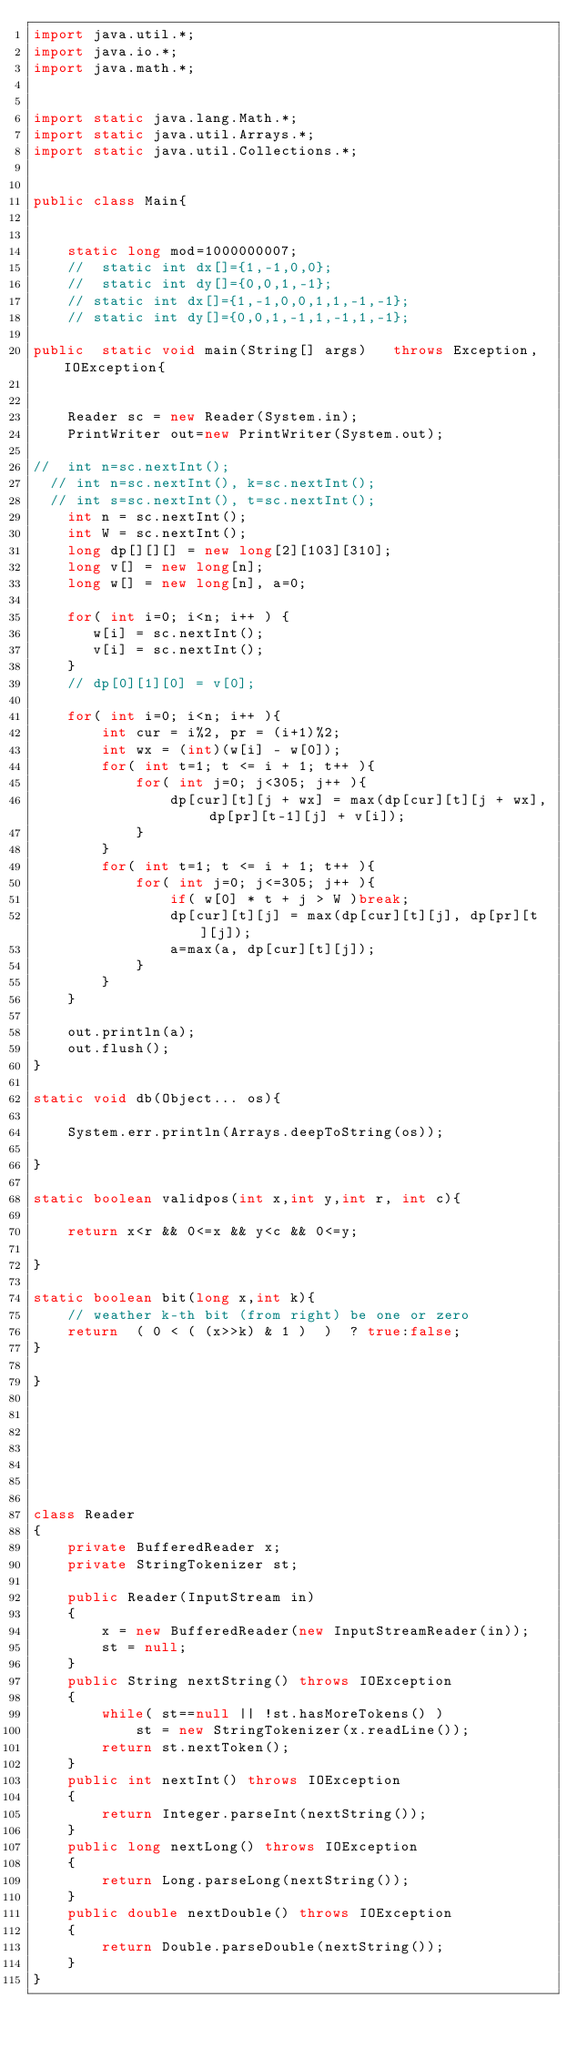<code> <loc_0><loc_0><loc_500><loc_500><_Java_>import java.util.*;
import java.io.*;
import java.math.*;


import static java.lang.Math.*;
import static java.util.Arrays.*;
import static java.util.Collections.*;


public class Main{ 


    static long mod=1000000007;
    //  static int dx[]={1,-1,0,0};
    //  static int dy[]={0,0,1,-1};
    // static int dx[]={1,-1,0,0,1,1,-1,-1};
    // static int dy[]={0,0,1,-1,1,-1,1,-1}; 

public  static void main(String[] args)   throws Exception, IOException{

    
    Reader sc = new Reader(System.in);
    PrintWriter out=new PrintWriter(System.out);

//  int n=sc.nextInt();  
  // int n=sc.nextInt(), k=sc.nextInt();  
  // int s=sc.nextInt(), t=sc.nextInt(); 
    int n = sc.nextInt();
    int W = sc.nextInt();
    long dp[][][] = new long[2][103][310];
    long v[] = new long[n];
    long w[] = new long[n], a=0;

    for( int i=0; i<n; i++ ) {
       w[i] = sc.nextInt();
       v[i] = sc.nextInt();
    }
    // dp[0][1][0] = v[0];

    for( int i=0; i<n; i++ ){
        int cur = i%2, pr = (i+1)%2;
        int wx = (int)(w[i] - w[0]); 
        for( int t=1; t <= i + 1; t++ ){
            for( int j=0; j<305; j++ ){
                dp[cur][t][j + wx] = max(dp[cur][t][j + wx], dp[pr][t-1][j] + v[i]);
            }
        }
        for( int t=1; t <= i + 1; t++ ){
            for( int j=0; j<=305; j++ ){
                if( w[0] * t + j > W )break;
                dp[cur][t][j] = max(dp[cur][t][j], dp[pr][t][j]);
                a=max(a, dp[cur][t][j]);
            }
        }
    }

    out.println(a);
    out.flush();
}

static void db(Object... os){

    System.err.println(Arrays.deepToString(os));

}

static boolean validpos(int x,int y,int r, int c){
    
    return x<r && 0<=x && y<c && 0<=y;
    
}
 
static boolean bit(long x,int k){
    // weather k-th bit (from right) be one or zero
    return  ( 0 < ( (x>>k) & 1 )  )  ? true:false;
}

}







class Reader
{ 
    private BufferedReader x;
    private StringTokenizer st;
    
    public Reader(InputStream in)
    {
        x = new BufferedReader(new InputStreamReader(in));
        st = null;
    }
    public String nextString() throws IOException
    {
        while( st==null || !st.hasMoreTokens() )
            st = new StringTokenizer(x.readLine());
        return st.nextToken();
    }
    public int nextInt() throws IOException
    {
        return Integer.parseInt(nextString());
    }
    public long nextLong() throws IOException
    {
        return Long.parseLong(nextString());
    }
    public double nextDouble() throws IOException
    {
        return Double.parseDouble(nextString());
    }
}

</code> 